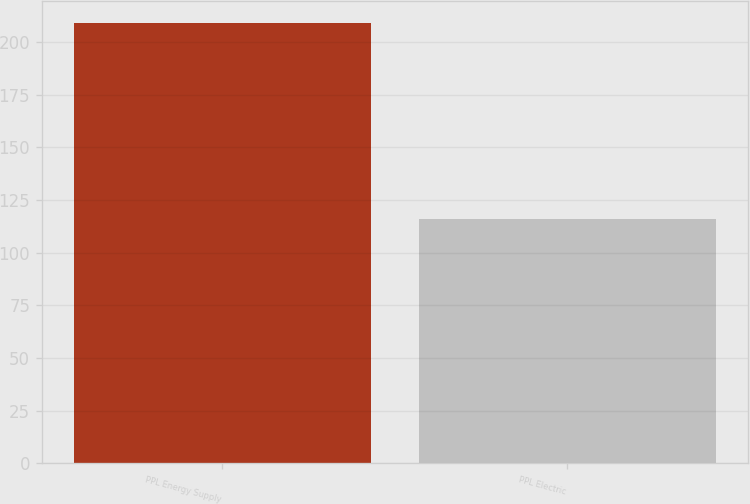Convert chart to OTSL. <chart><loc_0><loc_0><loc_500><loc_500><bar_chart><fcel>PPL Energy Supply<fcel>PPL Electric<nl><fcel>209<fcel>116<nl></chart> 